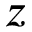Convert formula to latex. <formula><loc_0><loc_0><loc_500><loc_500>z</formula> 